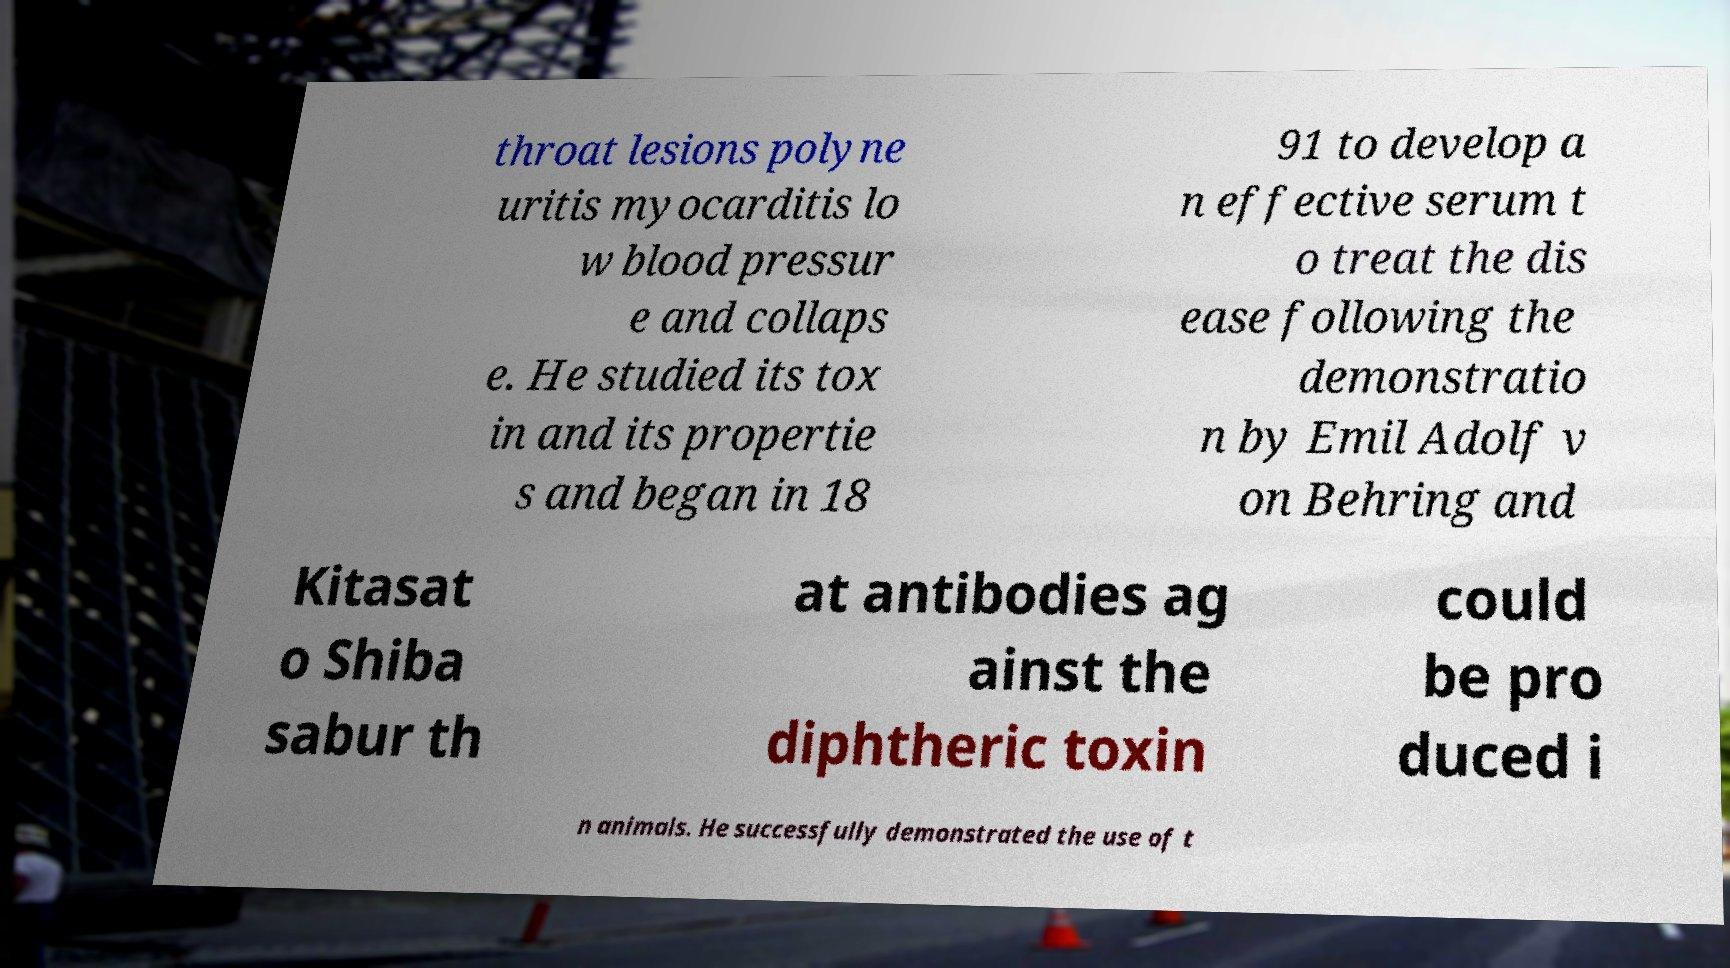Please read and relay the text visible in this image. What does it say? throat lesions polyne uritis myocarditis lo w blood pressur e and collaps e. He studied its tox in and its propertie s and began in 18 91 to develop a n effective serum t o treat the dis ease following the demonstratio n by Emil Adolf v on Behring and Kitasat o Shiba sabur th at antibodies ag ainst the diphtheric toxin could be pro duced i n animals. He successfully demonstrated the use of t 